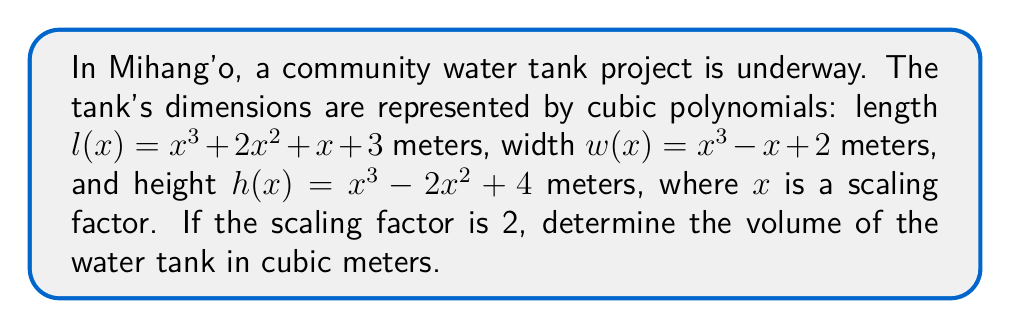Show me your answer to this math problem. To find the volume of the water tank, we need to:
1. Calculate the dimensions by substituting $x = 2$ into each polynomial.
2. Multiply the length, width, and height to get the volume.

Step 1: Calculate the dimensions

Length: $l(2) = 2^3 + 2(2^2) + 2 + 3$
$$\begin{align}
l(2) &= 8 + 2(4) + 2 + 3 \\
&= 8 + 8 + 2 + 3 \\
&= 21 \text{ meters}
\end{align}$$

Width: $w(2) = 2^3 - 2 + 2$
$$\begin{align}
w(2) &= 8 - 2 + 2 \\
&= 8 \text{ meters}
\end{align}$$

Height: $h(2) = 2^3 - 2(2^2) + 4$
$$\begin{align}
h(2) &= 8 - 2(4) + 4 \\
&= 8 - 8 + 4 \\
&= 4 \text{ meters}
\end{align}$$

Step 2: Calculate the volume

Volume = length × width × height
$$\begin{align}
V &= 21 \times 8 \times 4 \\
&= 672 \text{ cubic meters}
\end{align}$$
Answer: The volume of the water tank is 672 cubic meters. 